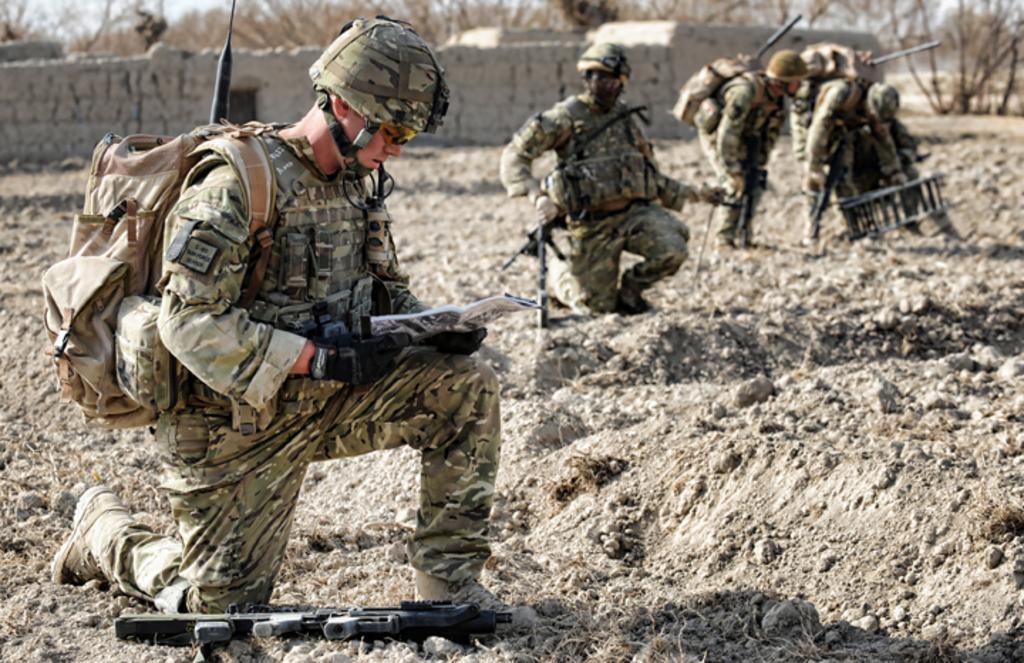In one or two sentences, can you explain what this image depicts? In this image we cam sees a group of people standing on the ground wearing military uniforms. one person is wearing a helmet and carrying a bag is holding a paper in his hand. In the foreground we can see a gun placed on the ground. In the background, we can see a wall and group of trees. 